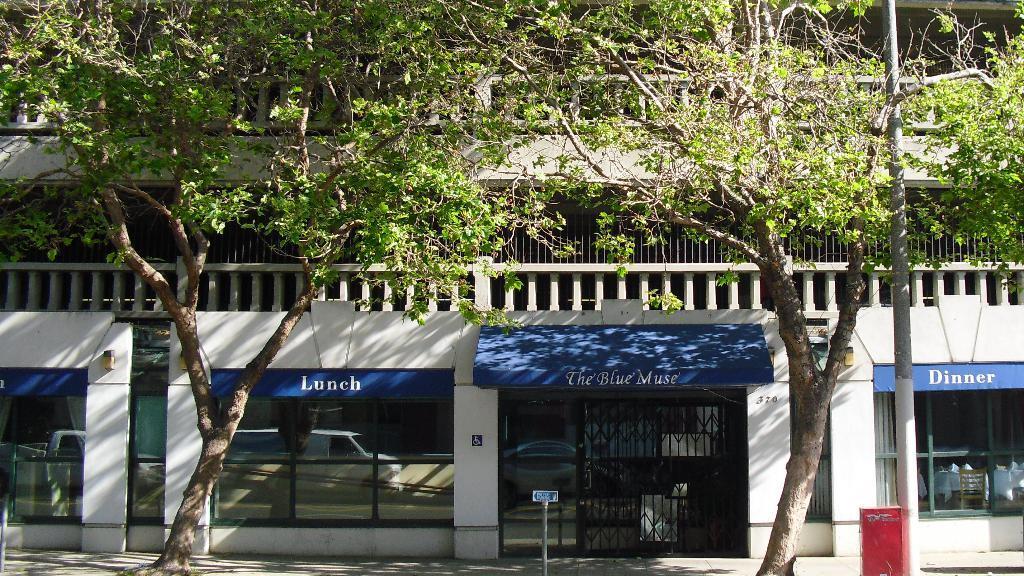Please provide a concise description of this image. In the foreground of the picture there are trees, pole, board, dustbin and footpath. In the middle of the picture we can see a building, to the building there are glass windows and a grill. In the glass windows we can see the reflection of a vehicle. 